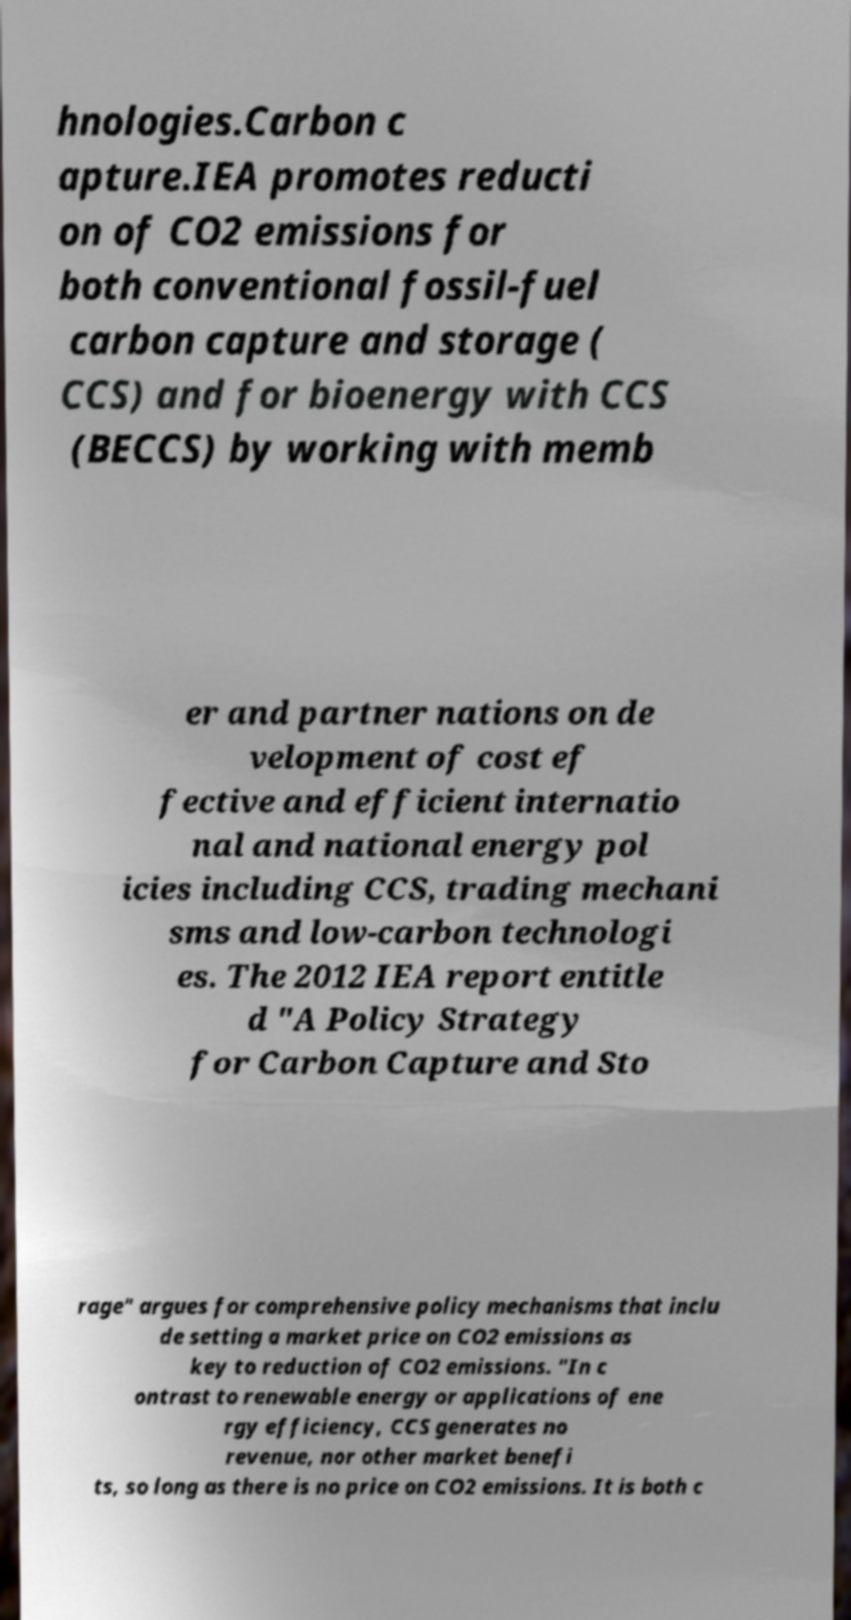There's text embedded in this image that I need extracted. Can you transcribe it verbatim? hnologies.Carbon c apture.IEA promotes reducti on of CO2 emissions for both conventional fossil-fuel carbon capture and storage ( CCS) and for bioenergy with CCS (BECCS) by working with memb er and partner nations on de velopment of cost ef fective and efficient internatio nal and national energy pol icies including CCS, trading mechani sms and low-carbon technologi es. The 2012 IEA report entitle d "A Policy Strategy for Carbon Capture and Sto rage" argues for comprehensive policy mechanisms that inclu de setting a market price on CO2 emissions as key to reduction of CO2 emissions. "In c ontrast to renewable energy or applications of ene rgy efficiency, CCS generates no revenue, nor other market benefi ts, so long as there is no price on CO2 emissions. It is both c 